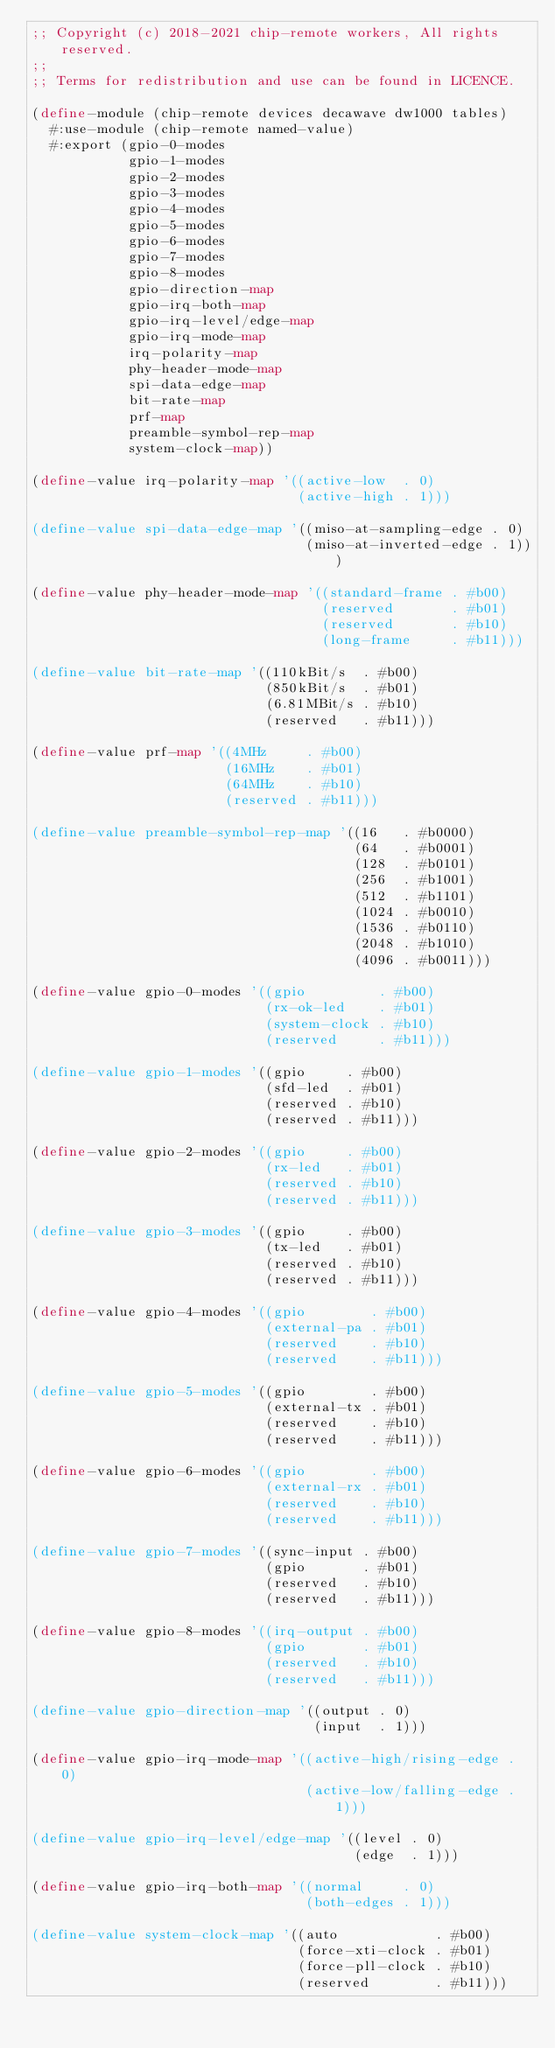<code> <loc_0><loc_0><loc_500><loc_500><_Scheme_>;; Copyright (c) 2018-2021 chip-remote workers, All rights reserved.
;;
;; Terms for redistribution and use can be found in LICENCE.

(define-module (chip-remote devices decawave dw1000 tables)
  #:use-module (chip-remote named-value)
  #:export (gpio-0-modes
            gpio-1-modes
            gpio-2-modes
            gpio-3-modes
            gpio-4-modes
            gpio-5-modes
            gpio-6-modes
            gpio-7-modes
            gpio-8-modes
            gpio-direction-map
            gpio-irq-both-map
            gpio-irq-level/edge-map
            gpio-irq-mode-map
            irq-polarity-map
            phy-header-mode-map
            spi-data-edge-map
            bit-rate-map
            prf-map
            preamble-symbol-rep-map
            system-clock-map))

(define-value irq-polarity-map '((active-low  . 0)
                                 (active-high . 1)))

(define-value spi-data-edge-map '((miso-at-sampling-edge . 0)
                                  (miso-at-inverted-edge . 1)))

(define-value phy-header-mode-map '((standard-frame . #b00)
                                    (reserved       . #b01)
                                    (reserved       . #b10)
                                    (long-frame     . #b11)))

(define-value bit-rate-map '((110kBit/s  . #b00)
                             (850kBit/s  . #b01)
                             (6.81MBit/s . #b10)
                             (reserved   . #b11)))

(define-value prf-map '((4MHz     . #b00)
                        (16MHz    . #b01)
                        (64MHz    . #b10)
                        (reserved . #b11)))

(define-value preamble-symbol-rep-map '((16   . #b0000)
                                        (64   . #b0001)
                                        (128  . #b0101)
                                        (256  . #b1001)
                                        (512  . #b1101)
                                        (1024 . #b0010)
                                        (1536 . #b0110)
                                        (2048 . #b1010)
                                        (4096 . #b0011)))

(define-value gpio-0-modes '((gpio         . #b00)
                             (rx-ok-led    . #b01)
                             (system-clock . #b10)
                             (reserved     . #b11)))

(define-value gpio-1-modes '((gpio     . #b00)
                             (sfd-led  . #b01)
                             (reserved . #b10)
                             (reserved . #b11)))

(define-value gpio-2-modes '((gpio     . #b00)
                             (rx-led   . #b01)
                             (reserved . #b10)
                             (reserved . #b11)))

(define-value gpio-3-modes '((gpio     . #b00)
                             (tx-led   . #b01)
                             (reserved . #b10)
                             (reserved . #b11)))

(define-value gpio-4-modes '((gpio        . #b00)
                             (external-pa . #b01)
                             (reserved    . #b10)
                             (reserved    . #b11)))

(define-value gpio-5-modes '((gpio        . #b00)
                             (external-tx . #b01)
                             (reserved    . #b10)
                             (reserved    . #b11)))

(define-value gpio-6-modes '((gpio        . #b00)
                             (external-rx . #b01)
                             (reserved    . #b10)
                             (reserved    . #b11)))

(define-value gpio-7-modes '((sync-input . #b00)
                             (gpio       . #b01)
                             (reserved   . #b10)
                             (reserved   . #b11)))

(define-value gpio-8-modes '((irq-output . #b00)
                             (gpio       . #b01)
                             (reserved   . #b10)
                             (reserved   . #b11)))

(define-value gpio-direction-map '((output . 0)
                                   (input  . 1)))

(define-value gpio-irq-mode-map '((active-high/rising-edge . 0)
                                  (active-low/falling-edge . 1)))

(define-value gpio-irq-level/edge-map '((level . 0)
                                        (edge  . 1)))

(define-value gpio-irq-both-map '((normal     . 0)
                                  (both-edges . 1)))

(define-value system-clock-map '((auto            . #b00)
                                 (force-xti-clock . #b01)
                                 (force-pll-clock . #b10)
                                 (reserved        . #b11)))
</code> 